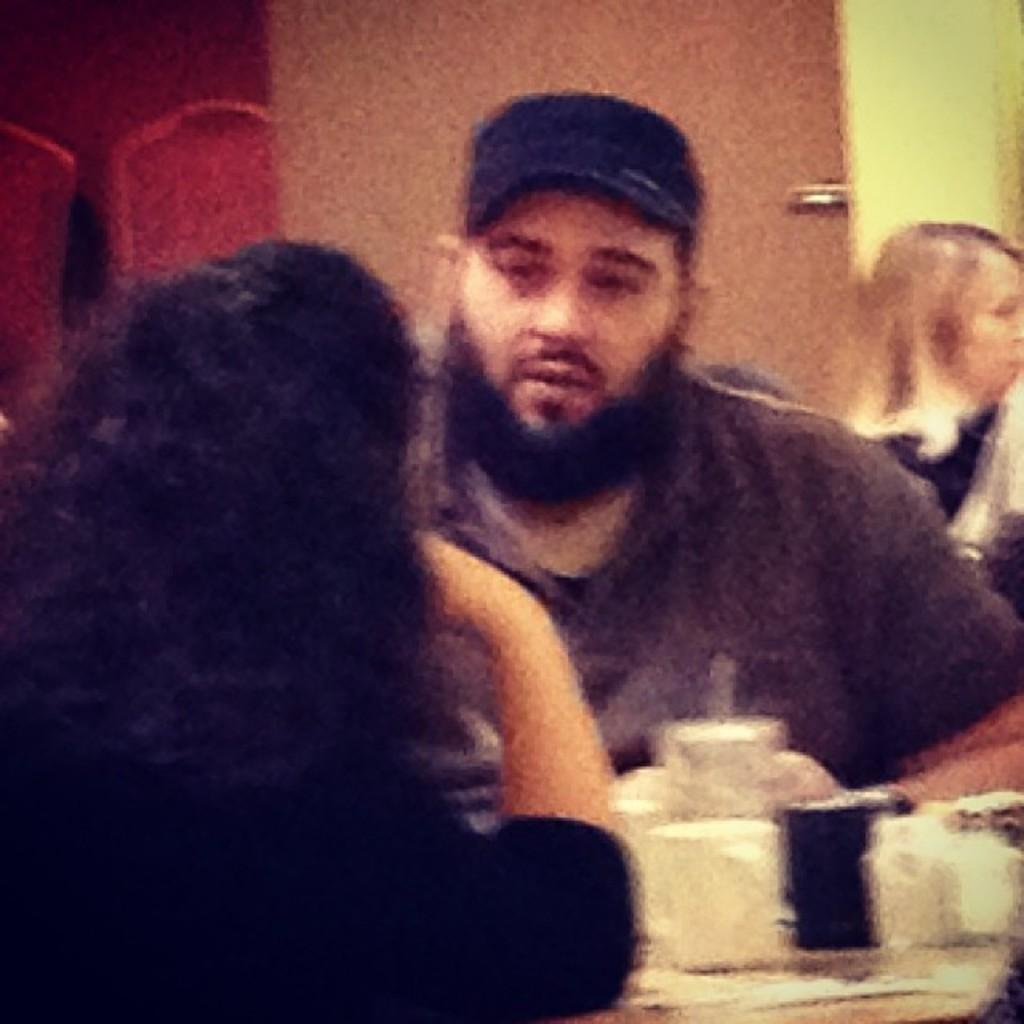What are the people in the image doing? The people in the image are seated. Can you describe the clothing of one of the individuals? A man is wearing a cap in the image. What objects can be seen on the table in the image? There are cups on a table in the image. How many pizzas are being served on the chairs in the image? There are no pizzas or chairs present in the image. What type of skin condition can be seen on the people in the image? There is no mention of any skin condition in the image; the people appear to be healthy. 